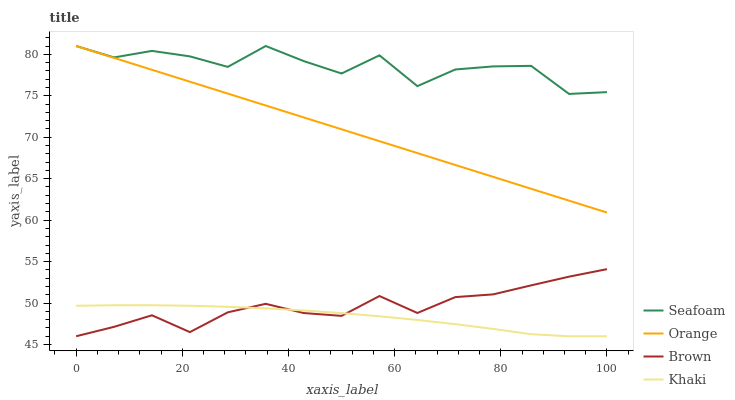Does Khaki have the minimum area under the curve?
Answer yes or no. Yes. Does Seafoam have the maximum area under the curve?
Answer yes or no. Yes. Does Brown have the minimum area under the curve?
Answer yes or no. No. Does Brown have the maximum area under the curve?
Answer yes or no. No. Is Orange the smoothest?
Answer yes or no. Yes. Is Seafoam the roughest?
Answer yes or no. Yes. Is Brown the smoothest?
Answer yes or no. No. Is Brown the roughest?
Answer yes or no. No. Does Brown have the lowest value?
Answer yes or no. Yes. Does Seafoam have the lowest value?
Answer yes or no. No. Does Seafoam have the highest value?
Answer yes or no. Yes. Does Brown have the highest value?
Answer yes or no. No. Is Brown less than Orange?
Answer yes or no. Yes. Is Seafoam greater than Brown?
Answer yes or no. Yes. Does Khaki intersect Brown?
Answer yes or no. Yes. Is Khaki less than Brown?
Answer yes or no. No. Is Khaki greater than Brown?
Answer yes or no. No. Does Brown intersect Orange?
Answer yes or no. No. 